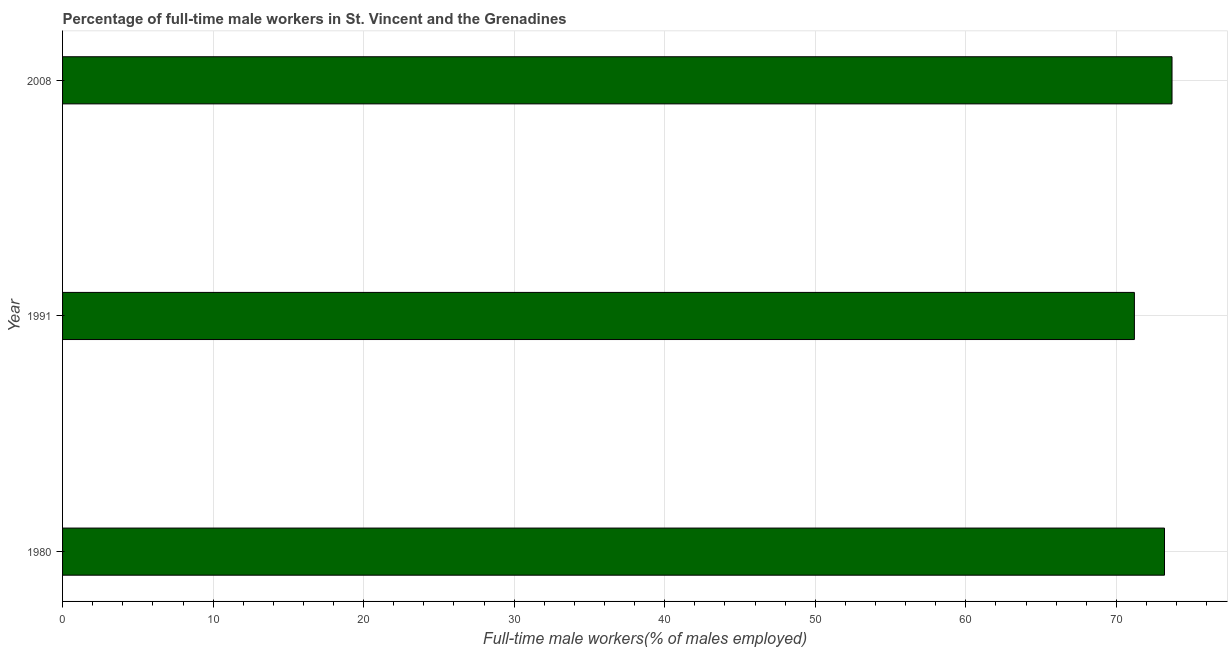What is the title of the graph?
Your response must be concise. Percentage of full-time male workers in St. Vincent and the Grenadines. What is the label or title of the X-axis?
Keep it short and to the point. Full-time male workers(% of males employed). What is the label or title of the Y-axis?
Your answer should be very brief. Year. What is the percentage of full-time male workers in 1991?
Keep it short and to the point. 71.2. Across all years, what is the maximum percentage of full-time male workers?
Make the answer very short. 73.7. Across all years, what is the minimum percentage of full-time male workers?
Make the answer very short. 71.2. In which year was the percentage of full-time male workers maximum?
Offer a very short reply. 2008. What is the sum of the percentage of full-time male workers?
Provide a short and direct response. 218.1. What is the average percentage of full-time male workers per year?
Your answer should be very brief. 72.7. What is the median percentage of full-time male workers?
Provide a short and direct response. 73.2. In how many years, is the percentage of full-time male workers greater than 12 %?
Ensure brevity in your answer.  3. What is the ratio of the percentage of full-time male workers in 1980 to that in 1991?
Make the answer very short. 1.03. Is the percentage of full-time male workers in 1980 less than that in 2008?
Ensure brevity in your answer.  Yes. Is the difference between the percentage of full-time male workers in 1991 and 2008 greater than the difference between any two years?
Offer a terse response. Yes. What is the difference between the highest and the second highest percentage of full-time male workers?
Provide a succinct answer. 0.5. Is the sum of the percentage of full-time male workers in 1980 and 2008 greater than the maximum percentage of full-time male workers across all years?
Your response must be concise. Yes. What is the difference between the highest and the lowest percentage of full-time male workers?
Your answer should be very brief. 2.5. Are all the bars in the graph horizontal?
Your response must be concise. Yes. How many years are there in the graph?
Offer a very short reply. 3. What is the difference between two consecutive major ticks on the X-axis?
Your response must be concise. 10. Are the values on the major ticks of X-axis written in scientific E-notation?
Your answer should be very brief. No. What is the Full-time male workers(% of males employed) in 1980?
Your answer should be compact. 73.2. What is the Full-time male workers(% of males employed) of 1991?
Give a very brief answer. 71.2. What is the Full-time male workers(% of males employed) in 2008?
Offer a very short reply. 73.7. What is the difference between the Full-time male workers(% of males employed) in 1980 and 1991?
Ensure brevity in your answer.  2. What is the difference between the Full-time male workers(% of males employed) in 1980 and 2008?
Your answer should be compact. -0.5. What is the difference between the Full-time male workers(% of males employed) in 1991 and 2008?
Give a very brief answer. -2.5. What is the ratio of the Full-time male workers(% of males employed) in 1980 to that in 1991?
Keep it short and to the point. 1.03. What is the ratio of the Full-time male workers(% of males employed) in 1980 to that in 2008?
Make the answer very short. 0.99. 